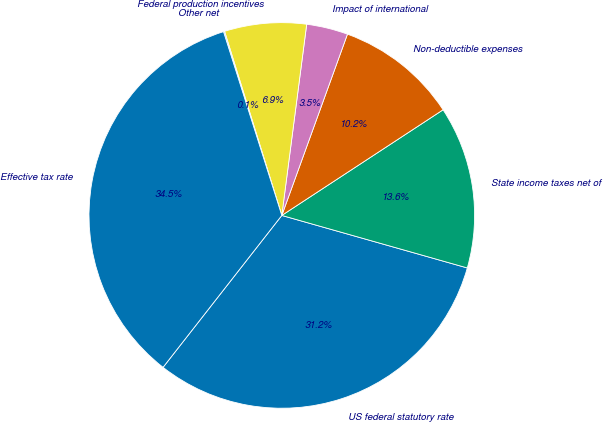Convert chart to OTSL. <chart><loc_0><loc_0><loc_500><loc_500><pie_chart><fcel>US federal statutory rate<fcel>State income taxes net of<fcel>Non-deductible expenses<fcel>Impact of international<fcel>Federal production incentives<fcel>Other net<fcel>Effective tax rate<nl><fcel>31.17%<fcel>13.62%<fcel>10.24%<fcel>3.47%<fcel>6.86%<fcel>0.09%<fcel>34.55%<nl></chart> 